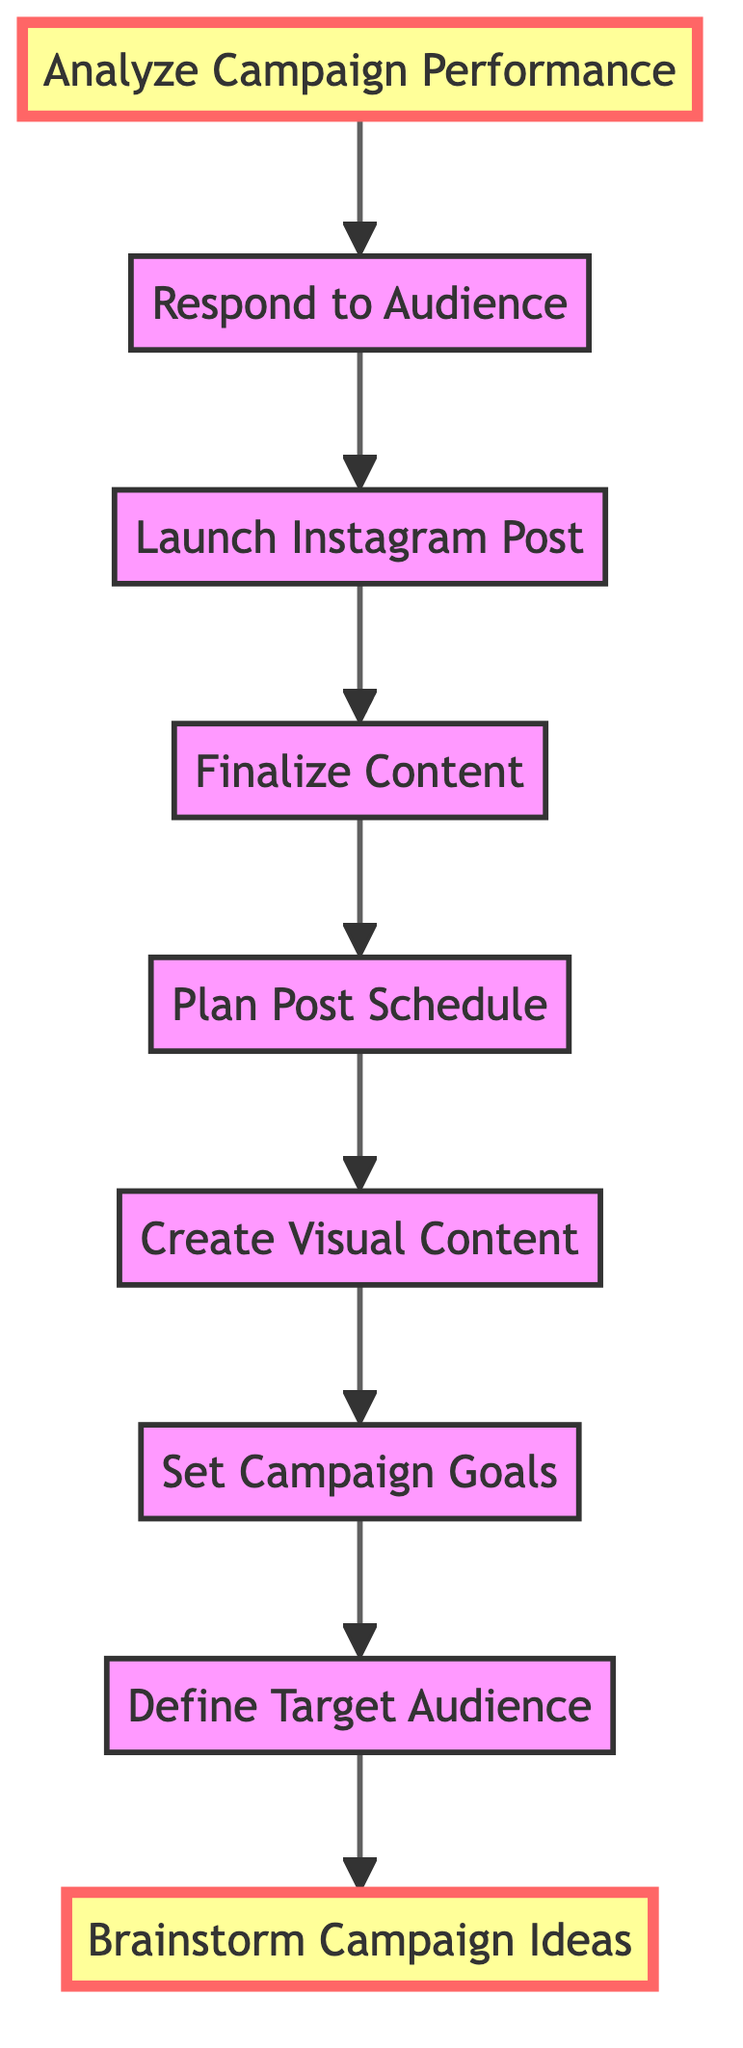What is the first step in the flowchart? The first step in the flowchart is "Brainstorm Campaign Ideas," which is located at the bottom of the chart.
Answer: Brainstorm Campaign Ideas What is the last step of the process? The last step is "Analyze Campaign Performance," which is the top node of the flowchart indicating the conclusion of the campaign process.
Answer: Analyze Campaign Performance How many nodes are present in the flowchart? The flowchart contains a total of 8 nodes, each representing a different step in managing the Instagram campaign.
Answer: 8 Which step directly follows "Create Visual Content"? "Plan Post Schedule" directly follows "Create Visual Content," indicating the sequence in which these tasks should be completed.
Answer: Plan Post Schedule What are the final two steps in the flowchart? The final two steps, working from the bottom up, are "Launch Instagram Post" and "Respond to Audience," which indicate actions taken after finalizing the content.
Answer: Launch Instagram Post, Respond to Audience What does "Set Campaign Goals" relate to? "Set Campaign Goals" relates to defining the intended outcomes for the Instagram campaign, which are needed before creating content or launching the post.
Answer: Define target audience Which two steps are highlighted in the diagram? The highlighted steps are "Analyze Campaign Performance" and "Brainstorm Campaign Ideas," indicating significant points in the flow.
Answer: Analyze Campaign Performance, Brainstorm Campaign Ideas What is the relationship between "Finalize Content" and "Launch Instagram Post"? "Finalize Content" must be completed before "Launch Instagram Post" because it’s essential to prepare the content before publishing it.
Answer: Finalize Content comes before Launch Instagram Post 